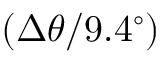Convert formula to latex. <formula><loc_0><loc_0><loc_500><loc_500>( \Delta \theta / 9 . 4 ^ { \circ } )</formula> 